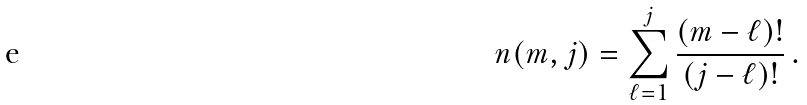Convert formula to latex. <formula><loc_0><loc_0><loc_500><loc_500>n ( m , j ) = \sum _ { \ell = 1 } ^ { j } \frac { ( m - \ell ) ! } { ( j - \ell ) ! } \, .</formula> 